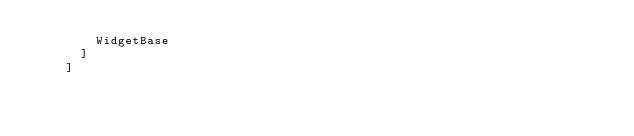Convert code to text. <code><loc_0><loc_0><loc_500><loc_500><_Scala_>        WidgetBase
      ]
    ]

</code> 